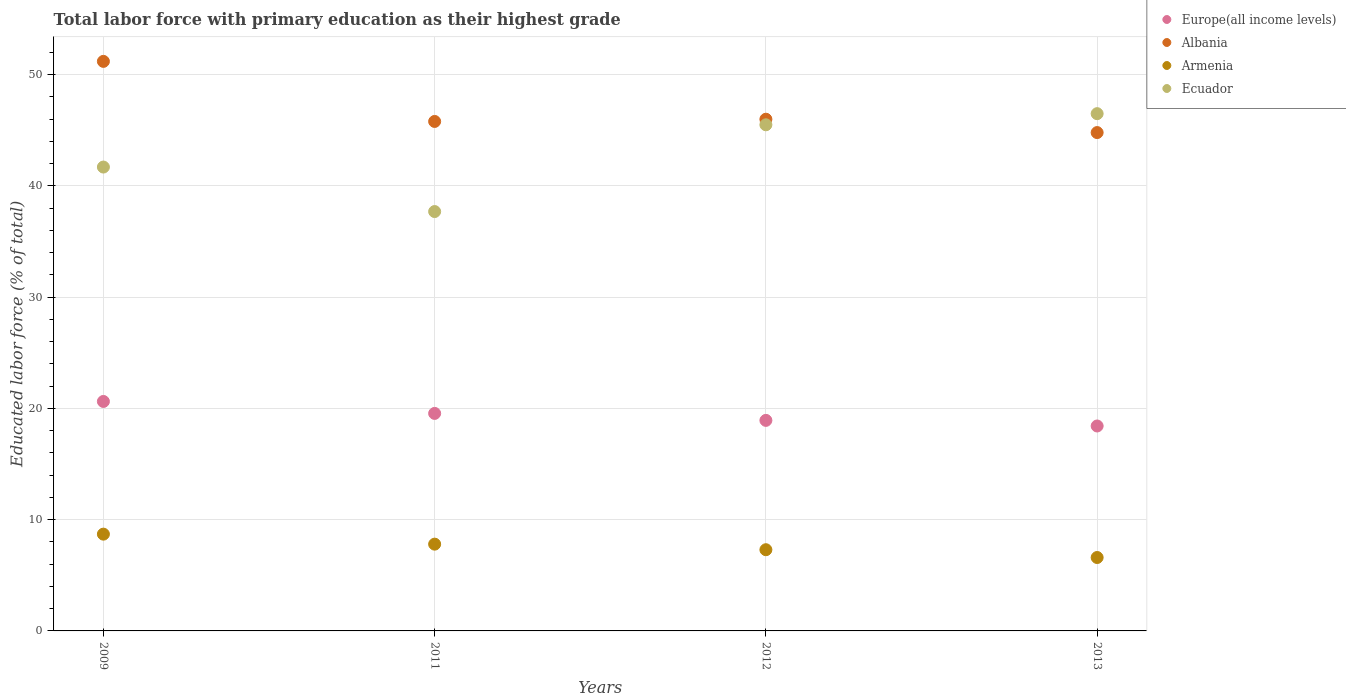How many different coloured dotlines are there?
Your response must be concise. 4. What is the percentage of total labor force with primary education in Albania in 2013?
Provide a short and direct response. 44.8. Across all years, what is the maximum percentage of total labor force with primary education in Albania?
Provide a succinct answer. 51.2. Across all years, what is the minimum percentage of total labor force with primary education in Albania?
Keep it short and to the point. 44.8. In which year was the percentage of total labor force with primary education in Ecuador minimum?
Give a very brief answer. 2011. What is the total percentage of total labor force with primary education in Armenia in the graph?
Your response must be concise. 30.4. What is the difference between the percentage of total labor force with primary education in Armenia in 2011 and the percentage of total labor force with primary education in Europe(all income levels) in 2013?
Make the answer very short. -10.62. What is the average percentage of total labor force with primary education in Europe(all income levels) per year?
Offer a terse response. 19.38. In the year 2011, what is the difference between the percentage of total labor force with primary education in Albania and percentage of total labor force with primary education in Europe(all income levels)?
Keep it short and to the point. 26.25. In how many years, is the percentage of total labor force with primary education in Europe(all income levels) greater than 50 %?
Your response must be concise. 0. What is the ratio of the percentage of total labor force with primary education in Armenia in 2011 to that in 2013?
Offer a very short reply. 1.18. Is the percentage of total labor force with primary education in Ecuador in 2009 less than that in 2013?
Offer a very short reply. Yes. Is the difference between the percentage of total labor force with primary education in Albania in 2012 and 2013 greater than the difference between the percentage of total labor force with primary education in Europe(all income levels) in 2012 and 2013?
Keep it short and to the point. Yes. What is the difference between the highest and the second highest percentage of total labor force with primary education in Armenia?
Your answer should be compact. 0.9. What is the difference between the highest and the lowest percentage of total labor force with primary education in Europe(all income levels)?
Your answer should be very brief. 2.21. In how many years, is the percentage of total labor force with primary education in Europe(all income levels) greater than the average percentage of total labor force with primary education in Europe(all income levels) taken over all years?
Offer a terse response. 2. Is the sum of the percentage of total labor force with primary education in Armenia in 2011 and 2012 greater than the maximum percentage of total labor force with primary education in Albania across all years?
Your answer should be compact. No. Is it the case that in every year, the sum of the percentage of total labor force with primary education in Europe(all income levels) and percentage of total labor force with primary education in Armenia  is greater than the percentage of total labor force with primary education in Ecuador?
Provide a short and direct response. No. Is the percentage of total labor force with primary education in Europe(all income levels) strictly less than the percentage of total labor force with primary education in Albania over the years?
Your response must be concise. Yes. How many dotlines are there?
Offer a terse response. 4. Does the graph contain any zero values?
Ensure brevity in your answer.  No. Does the graph contain grids?
Keep it short and to the point. Yes. Where does the legend appear in the graph?
Ensure brevity in your answer.  Top right. How many legend labels are there?
Ensure brevity in your answer.  4. What is the title of the graph?
Your answer should be compact. Total labor force with primary education as their highest grade. Does "Timor-Leste" appear as one of the legend labels in the graph?
Make the answer very short. No. What is the label or title of the X-axis?
Your response must be concise. Years. What is the label or title of the Y-axis?
Your answer should be very brief. Educated labor force (% of total). What is the Educated labor force (% of total) in Europe(all income levels) in 2009?
Your answer should be very brief. 20.63. What is the Educated labor force (% of total) in Albania in 2009?
Offer a terse response. 51.2. What is the Educated labor force (% of total) of Armenia in 2009?
Offer a very short reply. 8.7. What is the Educated labor force (% of total) in Ecuador in 2009?
Keep it short and to the point. 41.7. What is the Educated labor force (% of total) in Europe(all income levels) in 2011?
Your response must be concise. 19.55. What is the Educated labor force (% of total) of Albania in 2011?
Provide a succinct answer. 45.8. What is the Educated labor force (% of total) of Armenia in 2011?
Your answer should be very brief. 7.8. What is the Educated labor force (% of total) in Ecuador in 2011?
Ensure brevity in your answer.  37.7. What is the Educated labor force (% of total) in Europe(all income levels) in 2012?
Ensure brevity in your answer.  18.93. What is the Educated labor force (% of total) of Armenia in 2012?
Your response must be concise. 7.3. What is the Educated labor force (% of total) of Ecuador in 2012?
Offer a terse response. 45.5. What is the Educated labor force (% of total) of Europe(all income levels) in 2013?
Make the answer very short. 18.42. What is the Educated labor force (% of total) in Albania in 2013?
Make the answer very short. 44.8. What is the Educated labor force (% of total) of Armenia in 2013?
Your answer should be very brief. 6.6. What is the Educated labor force (% of total) of Ecuador in 2013?
Your answer should be compact. 46.5. Across all years, what is the maximum Educated labor force (% of total) of Europe(all income levels)?
Keep it short and to the point. 20.63. Across all years, what is the maximum Educated labor force (% of total) in Albania?
Your answer should be very brief. 51.2. Across all years, what is the maximum Educated labor force (% of total) in Armenia?
Offer a terse response. 8.7. Across all years, what is the maximum Educated labor force (% of total) in Ecuador?
Offer a terse response. 46.5. Across all years, what is the minimum Educated labor force (% of total) in Europe(all income levels)?
Offer a terse response. 18.42. Across all years, what is the minimum Educated labor force (% of total) in Albania?
Ensure brevity in your answer.  44.8. Across all years, what is the minimum Educated labor force (% of total) of Armenia?
Keep it short and to the point. 6.6. Across all years, what is the minimum Educated labor force (% of total) in Ecuador?
Keep it short and to the point. 37.7. What is the total Educated labor force (% of total) of Europe(all income levels) in the graph?
Give a very brief answer. 77.53. What is the total Educated labor force (% of total) in Albania in the graph?
Offer a very short reply. 187.8. What is the total Educated labor force (% of total) of Armenia in the graph?
Your answer should be compact. 30.4. What is the total Educated labor force (% of total) of Ecuador in the graph?
Keep it short and to the point. 171.4. What is the difference between the Educated labor force (% of total) of Europe(all income levels) in 2009 and that in 2011?
Keep it short and to the point. 1.07. What is the difference between the Educated labor force (% of total) of Albania in 2009 and that in 2011?
Offer a very short reply. 5.4. What is the difference between the Educated labor force (% of total) in Ecuador in 2009 and that in 2011?
Your answer should be very brief. 4. What is the difference between the Educated labor force (% of total) of Europe(all income levels) in 2009 and that in 2012?
Your response must be concise. 1.7. What is the difference between the Educated labor force (% of total) in Armenia in 2009 and that in 2012?
Make the answer very short. 1.4. What is the difference between the Educated labor force (% of total) in Ecuador in 2009 and that in 2012?
Ensure brevity in your answer.  -3.8. What is the difference between the Educated labor force (% of total) in Europe(all income levels) in 2009 and that in 2013?
Your response must be concise. 2.21. What is the difference between the Educated labor force (% of total) in Armenia in 2009 and that in 2013?
Provide a short and direct response. 2.1. What is the difference between the Educated labor force (% of total) of Europe(all income levels) in 2011 and that in 2012?
Provide a short and direct response. 0.63. What is the difference between the Educated labor force (% of total) in Armenia in 2011 and that in 2012?
Provide a succinct answer. 0.5. What is the difference between the Educated labor force (% of total) in Europe(all income levels) in 2011 and that in 2013?
Keep it short and to the point. 1.13. What is the difference between the Educated labor force (% of total) of Albania in 2011 and that in 2013?
Give a very brief answer. 1. What is the difference between the Educated labor force (% of total) in Europe(all income levels) in 2012 and that in 2013?
Your answer should be very brief. 0.5. What is the difference between the Educated labor force (% of total) in Albania in 2012 and that in 2013?
Your response must be concise. 1.2. What is the difference between the Educated labor force (% of total) of Europe(all income levels) in 2009 and the Educated labor force (% of total) of Albania in 2011?
Offer a terse response. -25.17. What is the difference between the Educated labor force (% of total) of Europe(all income levels) in 2009 and the Educated labor force (% of total) of Armenia in 2011?
Offer a very short reply. 12.83. What is the difference between the Educated labor force (% of total) of Europe(all income levels) in 2009 and the Educated labor force (% of total) of Ecuador in 2011?
Your response must be concise. -17.07. What is the difference between the Educated labor force (% of total) in Albania in 2009 and the Educated labor force (% of total) in Armenia in 2011?
Provide a short and direct response. 43.4. What is the difference between the Educated labor force (% of total) of Armenia in 2009 and the Educated labor force (% of total) of Ecuador in 2011?
Your response must be concise. -29. What is the difference between the Educated labor force (% of total) in Europe(all income levels) in 2009 and the Educated labor force (% of total) in Albania in 2012?
Offer a very short reply. -25.37. What is the difference between the Educated labor force (% of total) in Europe(all income levels) in 2009 and the Educated labor force (% of total) in Armenia in 2012?
Offer a very short reply. 13.33. What is the difference between the Educated labor force (% of total) in Europe(all income levels) in 2009 and the Educated labor force (% of total) in Ecuador in 2012?
Keep it short and to the point. -24.87. What is the difference between the Educated labor force (% of total) in Albania in 2009 and the Educated labor force (% of total) in Armenia in 2012?
Your answer should be compact. 43.9. What is the difference between the Educated labor force (% of total) of Albania in 2009 and the Educated labor force (% of total) of Ecuador in 2012?
Offer a very short reply. 5.7. What is the difference between the Educated labor force (% of total) in Armenia in 2009 and the Educated labor force (% of total) in Ecuador in 2012?
Give a very brief answer. -36.8. What is the difference between the Educated labor force (% of total) of Europe(all income levels) in 2009 and the Educated labor force (% of total) of Albania in 2013?
Your answer should be very brief. -24.17. What is the difference between the Educated labor force (% of total) of Europe(all income levels) in 2009 and the Educated labor force (% of total) of Armenia in 2013?
Give a very brief answer. 14.03. What is the difference between the Educated labor force (% of total) of Europe(all income levels) in 2009 and the Educated labor force (% of total) of Ecuador in 2013?
Your answer should be very brief. -25.87. What is the difference between the Educated labor force (% of total) in Albania in 2009 and the Educated labor force (% of total) in Armenia in 2013?
Offer a terse response. 44.6. What is the difference between the Educated labor force (% of total) of Albania in 2009 and the Educated labor force (% of total) of Ecuador in 2013?
Keep it short and to the point. 4.7. What is the difference between the Educated labor force (% of total) in Armenia in 2009 and the Educated labor force (% of total) in Ecuador in 2013?
Make the answer very short. -37.8. What is the difference between the Educated labor force (% of total) of Europe(all income levels) in 2011 and the Educated labor force (% of total) of Albania in 2012?
Make the answer very short. -26.45. What is the difference between the Educated labor force (% of total) in Europe(all income levels) in 2011 and the Educated labor force (% of total) in Armenia in 2012?
Your response must be concise. 12.25. What is the difference between the Educated labor force (% of total) of Europe(all income levels) in 2011 and the Educated labor force (% of total) of Ecuador in 2012?
Your response must be concise. -25.95. What is the difference between the Educated labor force (% of total) in Albania in 2011 and the Educated labor force (% of total) in Armenia in 2012?
Your answer should be very brief. 38.5. What is the difference between the Educated labor force (% of total) in Armenia in 2011 and the Educated labor force (% of total) in Ecuador in 2012?
Your response must be concise. -37.7. What is the difference between the Educated labor force (% of total) of Europe(all income levels) in 2011 and the Educated labor force (% of total) of Albania in 2013?
Your response must be concise. -25.25. What is the difference between the Educated labor force (% of total) in Europe(all income levels) in 2011 and the Educated labor force (% of total) in Armenia in 2013?
Ensure brevity in your answer.  12.95. What is the difference between the Educated labor force (% of total) of Europe(all income levels) in 2011 and the Educated labor force (% of total) of Ecuador in 2013?
Ensure brevity in your answer.  -26.95. What is the difference between the Educated labor force (% of total) in Albania in 2011 and the Educated labor force (% of total) in Armenia in 2013?
Offer a terse response. 39.2. What is the difference between the Educated labor force (% of total) in Albania in 2011 and the Educated labor force (% of total) in Ecuador in 2013?
Ensure brevity in your answer.  -0.7. What is the difference between the Educated labor force (% of total) of Armenia in 2011 and the Educated labor force (% of total) of Ecuador in 2013?
Your answer should be very brief. -38.7. What is the difference between the Educated labor force (% of total) of Europe(all income levels) in 2012 and the Educated labor force (% of total) of Albania in 2013?
Your answer should be compact. -25.87. What is the difference between the Educated labor force (% of total) of Europe(all income levels) in 2012 and the Educated labor force (% of total) of Armenia in 2013?
Provide a succinct answer. 12.33. What is the difference between the Educated labor force (% of total) of Europe(all income levels) in 2012 and the Educated labor force (% of total) of Ecuador in 2013?
Provide a succinct answer. -27.57. What is the difference between the Educated labor force (% of total) of Albania in 2012 and the Educated labor force (% of total) of Armenia in 2013?
Make the answer very short. 39.4. What is the difference between the Educated labor force (% of total) in Albania in 2012 and the Educated labor force (% of total) in Ecuador in 2013?
Keep it short and to the point. -0.5. What is the difference between the Educated labor force (% of total) of Armenia in 2012 and the Educated labor force (% of total) of Ecuador in 2013?
Make the answer very short. -39.2. What is the average Educated labor force (% of total) in Europe(all income levels) per year?
Your answer should be very brief. 19.38. What is the average Educated labor force (% of total) in Albania per year?
Offer a very short reply. 46.95. What is the average Educated labor force (% of total) in Ecuador per year?
Your answer should be very brief. 42.85. In the year 2009, what is the difference between the Educated labor force (% of total) in Europe(all income levels) and Educated labor force (% of total) in Albania?
Offer a very short reply. -30.57. In the year 2009, what is the difference between the Educated labor force (% of total) in Europe(all income levels) and Educated labor force (% of total) in Armenia?
Offer a terse response. 11.93. In the year 2009, what is the difference between the Educated labor force (% of total) of Europe(all income levels) and Educated labor force (% of total) of Ecuador?
Make the answer very short. -21.07. In the year 2009, what is the difference between the Educated labor force (% of total) of Albania and Educated labor force (% of total) of Armenia?
Offer a very short reply. 42.5. In the year 2009, what is the difference between the Educated labor force (% of total) of Albania and Educated labor force (% of total) of Ecuador?
Provide a short and direct response. 9.5. In the year 2009, what is the difference between the Educated labor force (% of total) in Armenia and Educated labor force (% of total) in Ecuador?
Your response must be concise. -33. In the year 2011, what is the difference between the Educated labor force (% of total) in Europe(all income levels) and Educated labor force (% of total) in Albania?
Keep it short and to the point. -26.25. In the year 2011, what is the difference between the Educated labor force (% of total) in Europe(all income levels) and Educated labor force (% of total) in Armenia?
Keep it short and to the point. 11.75. In the year 2011, what is the difference between the Educated labor force (% of total) of Europe(all income levels) and Educated labor force (% of total) of Ecuador?
Ensure brevity in your answer.  -18.15. In the year 2011, what is the difference between the Educated labor force (% of total) in Armenia and Educated labor force (% of total) in Ecuador?
Provide a succinct answer. -29.9. In the year 2012, what is the difference between the Educated labor force (% of total) of Europe(all income levels) and Educated labor force (% of total) of Albania?
Provide a succinct answer. -27.07. In the year 2012, what is the difference between the Educated labor force (% of total) of Europe(all income levels) and Educated labor force (% of total) of Armenia?
Offer a terse response. 11.63. In the year 2012, what is the difference between the Educated labor force (% of total) in Europe(all income levels) and Educated labor force (% of total) in Ecuador?
Provide a succinct answer. -26.57. In the year 2012, what is the difference between the Educated labor force (% of total) of Albania and Educated labor force (% of total) of Armenia?
Your response must be concise. 38.7. In the year 2012, what is the difference between the Educated labor force (% of total) of Armenia and Educated labor force (% of total) of Ecuador?
Make the answer very short. -38.2. In the year 2013, what is the difference between the Educated labor force (% of total) of Europe(all income levels) and Educated labor force (% of total) of Albania?
Keep it short and to the point. -26.38. In the year 2013, what is the difference between the Educated labor force (% of total) in Europe(all income levels) and Educated labor force (% of total) in Armenia?
Provide a succinct answer. 11.82. In the year 2013, what is the difference between the Educated labor force (% of total) in Europe(all income levels) and Educated labor force (% of total) in Ecuador?
Provide a succinct answer. -28.08. In the year 2013, what is the difference between the Educated labor force (% of total) in Albania and Educated labor force (% of total) in Armenia?
Your response must be concise. 38.2. In the year 2013, what is the difference between the Educated labor force (% of total) in Armenia and Educated labor force (% of total) in Ecuador?
Your response must be concise. -39.9. What is the ratio of the Educated labor force (% of total) in Europe(all income levels) in 2009 to that in 2011?
Ensure brevity in your answer.  1.05. What is the ratio of the Educated labor force (% of total) of Albania in 2009 to that in 2011?
Give a very brief answer. 1.12. What is the ratio of the Educated labor force (% of total) in Armenia in 2009 to that in 2011?
Make the answer very short. 1.12. What is the ratio of the Educated labor force (% of total) in Ecuador in 2009 to that in 2011?
Provide a short and direct response. 1.11. What is the ratio of the Educated labor force (% of total) of Europe(all income levels) in 2009 to that in 2012?
Ensure brevity in your answer.  1.09. What is the ratio of the Educated labor force (% of total) of Albania in 2009 to that in 2012?
Ensure brevity in your answer.  1.11. What is the ratio of the Educated labor force (% of total) of Armenia in 2009 to that in 2012?
Provide a short and direct response. 1.19. What is the ratio of the Educated labor force (% of total) of Ecuador in 2009 to that in 2012?
Keep it short and to the point. 0.92. What is the ratio of the Educated labor force (% of total) in Europe(all income levels) in 2009 to that in 2013?
Keep it short and to the point. 1.12. What is the ratio of the Educated labor force (% of total) in Armenia in 2009 to that in 2013?
Your answer should be compact. 1.32. What is the ratio of the Educated labor force (% of total) in Ecuador in 2009 to that in 2013?
Keep it short and to the point. 0.9. What is the ratio of the Educated labor force (% of total) in Europe(all income levels) in 2011 to that in 2012?
Offer a terse response. 1.03. What is the ratio of the Educated labor force (% of total) of Albania in 2011 to that in 2012?
Provide a succinct answer. 1. What is the ratio of the Educated labor force (% of total) of Armenia in 2011 to that in 2012?
Make the answer very short. 1.07. What is the ratio of the Educated labor force (% of total) of Ecuador in 2011 to that in 2012?
Provide a short and direct response. 0.83. What is the ratio of the Educated labor force (% of total) in Europe(all income levels) in 2011 to that in 2013?
Keep it short and to the point. 1.06. What is the ratio of the Educated labor force (% of total) of Albania in 2011 to that in 2013?
Your answer should be very brief. 1.02. What is the ratio of the Educated labor force (% of total) of Armenia in 2011 to that in 2013?
Provide a short and direct response. 1.18. What is the ratio of the Educated labor force (% of total) of Ecuador in 2011 to that in 2013?
Offer a very short reply. 0.81. What is the ratio of the Educated labor force (% of total) of Europe(all income levels) in 2012 to that in 2013?
Offer a very short reply. 1.03. What is the ratio of the Educated labor force (% of total) of Albania in 2012 to that in 2013?
Your answer should be very brief. 1.03. What is the ratio of the Educated labor force (% of total) in Armenia in 2012 to that in 2013?
Make the answer very short. 1.11. What is the ratio of the Educated labor force (% of total) in Ecuador in 2012 to that in 2013?
Offer a very short reply. 0.98. What is the difference between the highest and the second highest Educated labor force (% of total) of Europe(all income levels)?
Your response must be concise. 1.07. What is the difference between the highest and the second highest Educated labor force (% of total) of Albania?
Offer a very short reply. 5.2. What is the difference between the highest and the second highest Educated labor force (% of total) in Armenia?
Your response must be concise. 0.9. What is the difference between the highest and the lowest Educated labor force (% of total) of Europe(all income levels)?
Your response must be concise. 2.21. What is the difference between the highest and the lowest Educated labor force (% of total) of Albania?
Keep it short and to the point. 6.4. What is the difference between the highest and the lowest Educated labor force (% of total) of Armenia?
Offer a terse response. 2.1. 